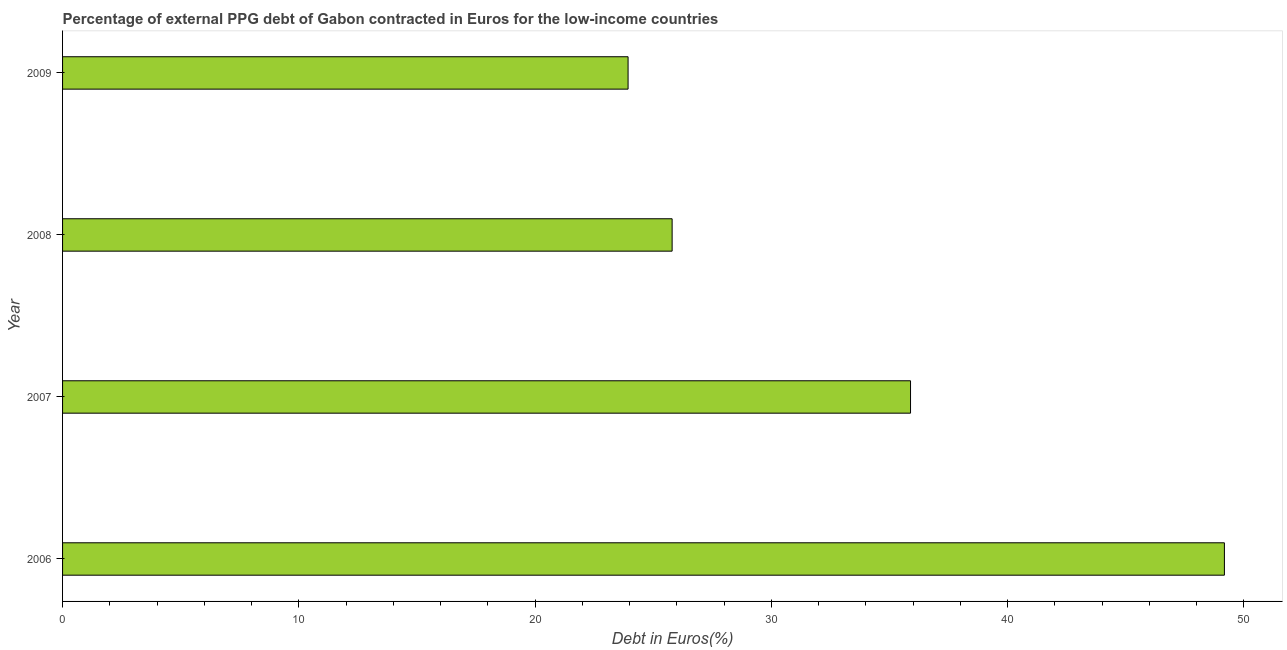Does the graph contain any zero values?
Offer a very short reply. No. Does the graph contain grids?
Make the answer very short. No. What is the title of the graph?
Keep it short and to the point. Percentage of external PPG debt of Gabon contracted in Euros for the low-income countries. What is the label or title of the X-axis?
Keep it short and to the point. Debt in Euros(%). What is the currency composition of ppg debt in 2006?
Provide a succinct answer. 49.18. Across all years, what is the maximum currency composition of ppg debt?
Provide a succinct answer. 49.18. Across all years, what is the minimum currency composition of ppg debt?
Provide a succinct answer. 23.94. In which year was the currency composition of ppg debt minimum?
Keep it short and to the point. 2009. What is the sum of the currency composition of ppg debt?
Give a very brief answer. 134.81. What is the difference between the currency composition of ppg debt in 2006 and 2007?
Your answer should be compact. 13.29. What is the average currency composition of ppg debt per year?
Provide a short and direct response. 33.7. What is the median currency composition of ppg debt?
Your response must be concise. 30.85. In how many years, is the currency composition of ppg debt greater than 46 %?
Offer a very short reply. 1. Do a majority of the years between 2009 and 2006 (inclusive) have currency composition of ppg debt greater than 16 %?
Ensure brevity in your answer.  Yes. What is the ratio of the currency composition of ppg debt in 2008 to that in 2009?
Give a very brief answer. 1.08. What is the difference between the highest and the second highest currency composition of ppg debt?
Offer a terse response. 13.29. Is the sum of the currency composition of ppg debt in 2007 and 2009 greater than the maximum currency composition of ppg debt across all years?
Provide a succinct answer. Yes. What is the difference between the highest and the lowest currency composition of ppg debt?
Give a very brief answer. 25.24. In how many years, is the currency composition of ppg debt greater than the average currency composition of ppg debt taken over all years?
Your answer should be very brief. 2. How many bars are there?
Offer a very short reply. 4. What is the difference between two consecutive major ticks on the X-axis?
Provide a short and direct response. 10. What is the Debt in Euros(%) in 2006?
Your answer should be compact. 49.18. What is the Debt in Euros(%) of 2007?
Keep it short and to the point. 35.89. What is the Debt in Euros(%) in 2008?
Your answer should be compact. 25.8. What is the Debt in Euros(%) in 2009?
Provide a short and direct response. 23.94. What is the difference between the Debt in Euros(%) in 2006 and 2007?
Provide a short and direct response. 13.29. What is the difference between the Debt in Euros(%) in 2006 and 2008?
Make the answer very short. 23.38. What is the difference between the Debt in Euros(%) in 2006 and 2009?
Provide a succinct answer. 25.24. What is the difference between the Debt in Euros(%) in 2007 and 2008?
Provide a succinct answer. 10.09. What is the difference between the Debt in Euros(%) in 2007 and 2009?
Provide a succinct answer. 11.96. What is the difference between the Debt in Euros(%) in 2008 and 2009?
Give a very brief answer. 1.86. What is the ratio of the Debt in Euros(%) in 2006 to that in 2007?
Your answer should be very brief. 1.37. What is the ratio of the Debt in Euros(%) in 2006 to that in 2008?
Your answer should be compact. 1.91. What is the ratio of the Debt in Euros(%) in 2006 to that in 2009?
Your answer should be very brief. 2.05. What is the ratio of the Debt in Euros(%) in 2007 to that in 2008?
Your answer should be compact. 1.39. What is the ratio of the Debt in Euros(%) in 2007 to that in 2009?
Provide a succinct answer. 1.5. What is the ratio of the Debt in Euros(%) in 2008 to that in 2009?
Give a very brief answer. 1.08. 